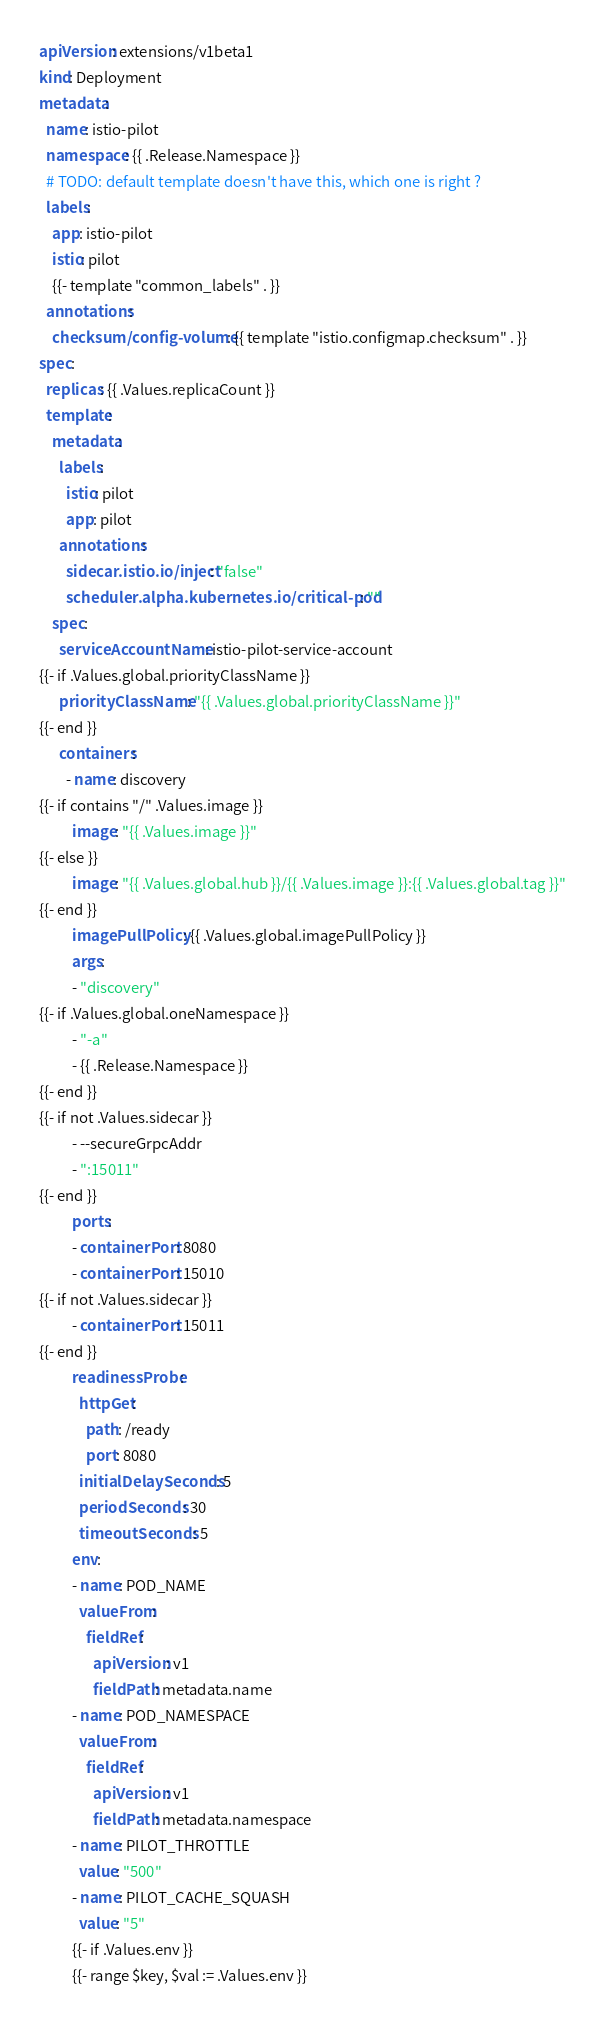<code> <loc_0><loc_0><loc_500><loc_500><_YAML_>apiVersion: extensions/v1beta1
kind: Deployment
metadata:
  name: istio-pilot
  namespace: {{ .Release.Namespace }}
  # TODO: default template doesn't have this, which one is right ?
  labels:
    app: istio-pilot
    istio: pilot
    {{- template "common_labels" . }}
  annotations:
    checksum/config-volume: {{ template "istio.configmap.checksum" . }}
spec:
  replicas: {{ .Values.replicaCount }}
  template:
    metadata:
      labels:
        istio: pilot
        app: pilot
      annotations:
        sidecar.istio.io/inject: "false"
        scheduler.alpha.kubernetes.io/critical-pod: ""
    spec:
      serviceAccountName: istio-pilot-service-account
{{- if .Values.global.priorityClassName }}
      priorityClassName: "{{ .Values.global.priorityClassName }}"
{{- end }}
      containers:
        - name: discovery
{{- if contains "/" .Values.image }}
          image: "{{ .Values.image }}"
{{- else }}
          image: "{{ .Values.global.hub }}/{{ .Values.image }}:{{ .Values.global.tag }}"
{{- end }}
          imagePullPolicy: {{ .Values.global.imagePullPolicy }}
          args:
          - "discovery"
{{- if .Values.global.oneNamespace }}
          - "-a"
          - {{ .Release.Namespace }}
{{- end }}
{{- if not .Values.sidecar }}
          - --secureGrpcAddr
          - ":15011"
{{- end }}
          ports:
          - containerPort: 8080
          - containerPort: 15010
{{- if not .Values.sidecar }}
          - containerPort: 15011
{{- end }}
          readinessProbe:
            httpGet:
              path: /ready
              port: 8080
            initialDelaySeconds: 5
            periodSeconds: 30
            timeoutSeconds: 5
          env:
          - name: POD_NAME
            valueFrom:
              fieldRef:
                apiVersion: v1
                fieldPath: metadata.name
          - name: POD_NAMESPACE
            valueFrom:
              fieldRef:
                apiVersion: v1
                fieldPath: metadata.namespace
          - name: PILOT_THROTTLE
            value: "500"
          - name: PILOT_CACHE_SQUASH
            value: "5"
          {{- if .Values.env }}
          {{- range $key, $val := .Values.env }}</code> 